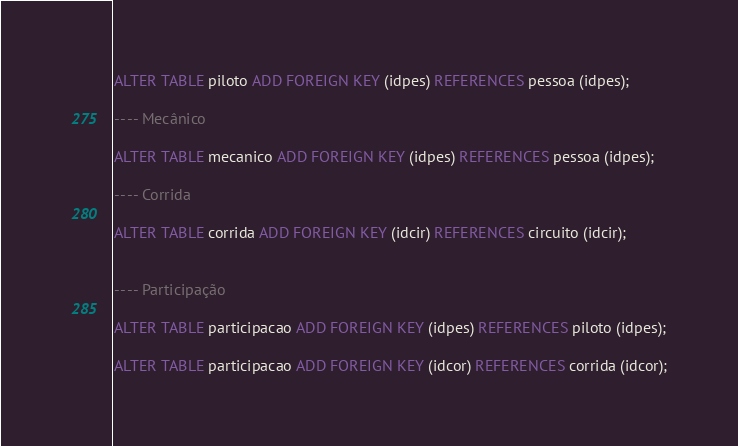Convert code to text. <code><loc_0><loc_0><loc_500><loc_500><_SQL_>
ALTER TABLE piloto ADD FOREIGN KEY (idpes) REFERENCES pessoa (idpes);

-- -- Mecânico

ALTER TABLE mecanico ADD FOREIGN KEY (idpes) REFERENCES pessoa (idpes);

-- -- Corrida

ALTER TABLE corrida ADD FOREIGN KEY (idcir) REFERENCES circuito (idcir);


-- -- Participação

ALTER TABLE participacao ADD FOREIGN KEY (idpes) REFERENCES piloto (idpes);

ALTER TABLE participacao ADD FOREIGN KEY (idcor) REFERENCES corrida (idcor);

</code> 